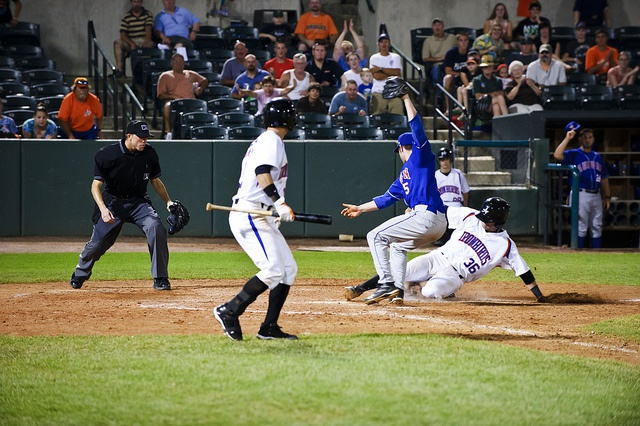Describe the objects in this image and their specific colors. I can see people in black, gray, and maroon tones, people in black, gray, and olive tones, people in black, white, and darkgray tones, people in black, lavender, navy, and darkgray tones, and people in black, lavender, and darkgray tones in this image. 